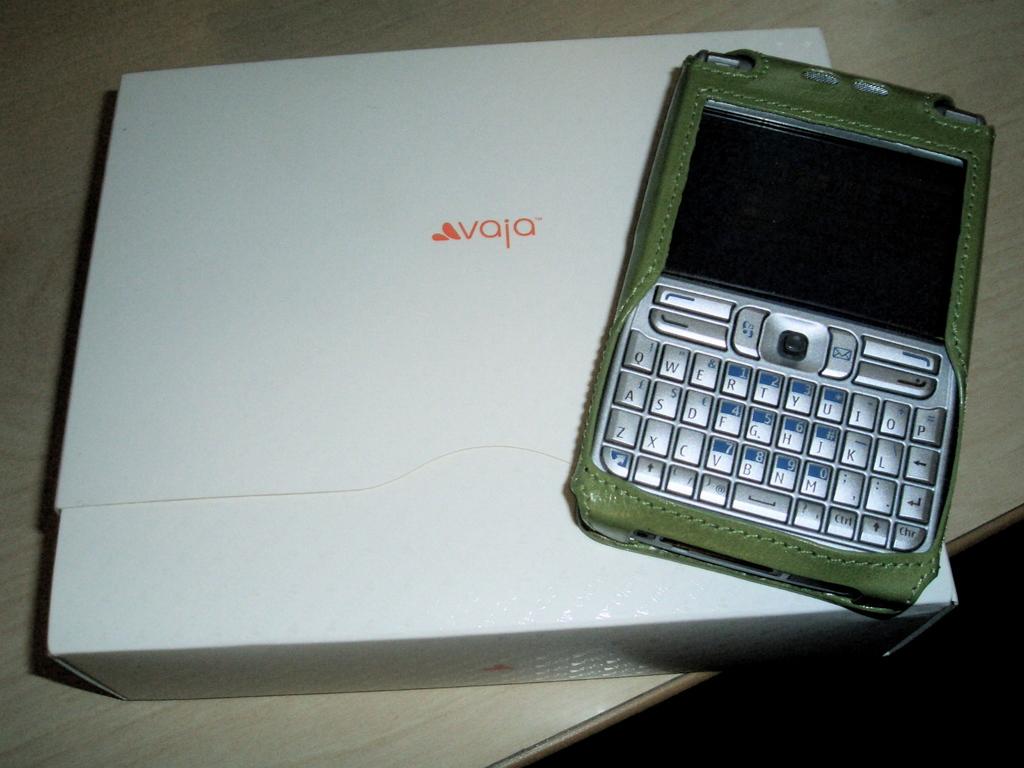What brand of phone is that?
Provide a short and direct response. Vaja. What brand is this?
Offer a terse response. Vaja. 